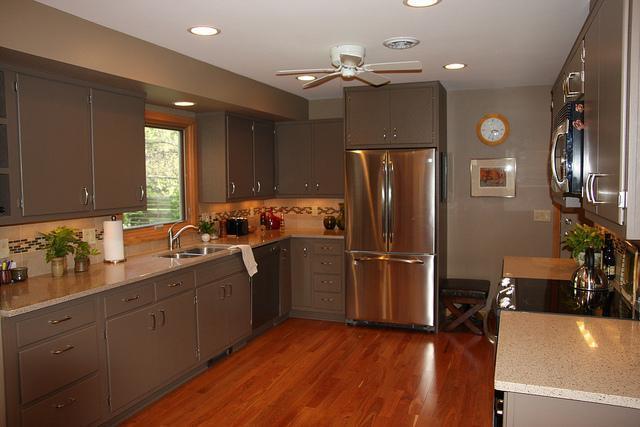How many plants are there?
Give a very brief answer. 4. 